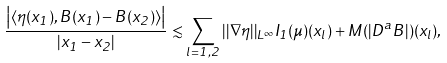<formula> <loc_0><loc_0><loc_500><loc_500>\frac { \left | \langle \eta ( x _ { 1 } ) , B ( x _ { 1 } ) - B ( x _ { 2 } ) \rangle \right | } { | x _ { 1 } - x _ { 2 } | } \lesssim \sum _ { l = 1 , 2 } | | \nabla \eta | | _ { L ^ { \infty } } I _ { 1 } ( \mu ) ( x _ { l } ) + M ( | D ^ { a } B | ) ( x _ { l } ) ,</formula> 